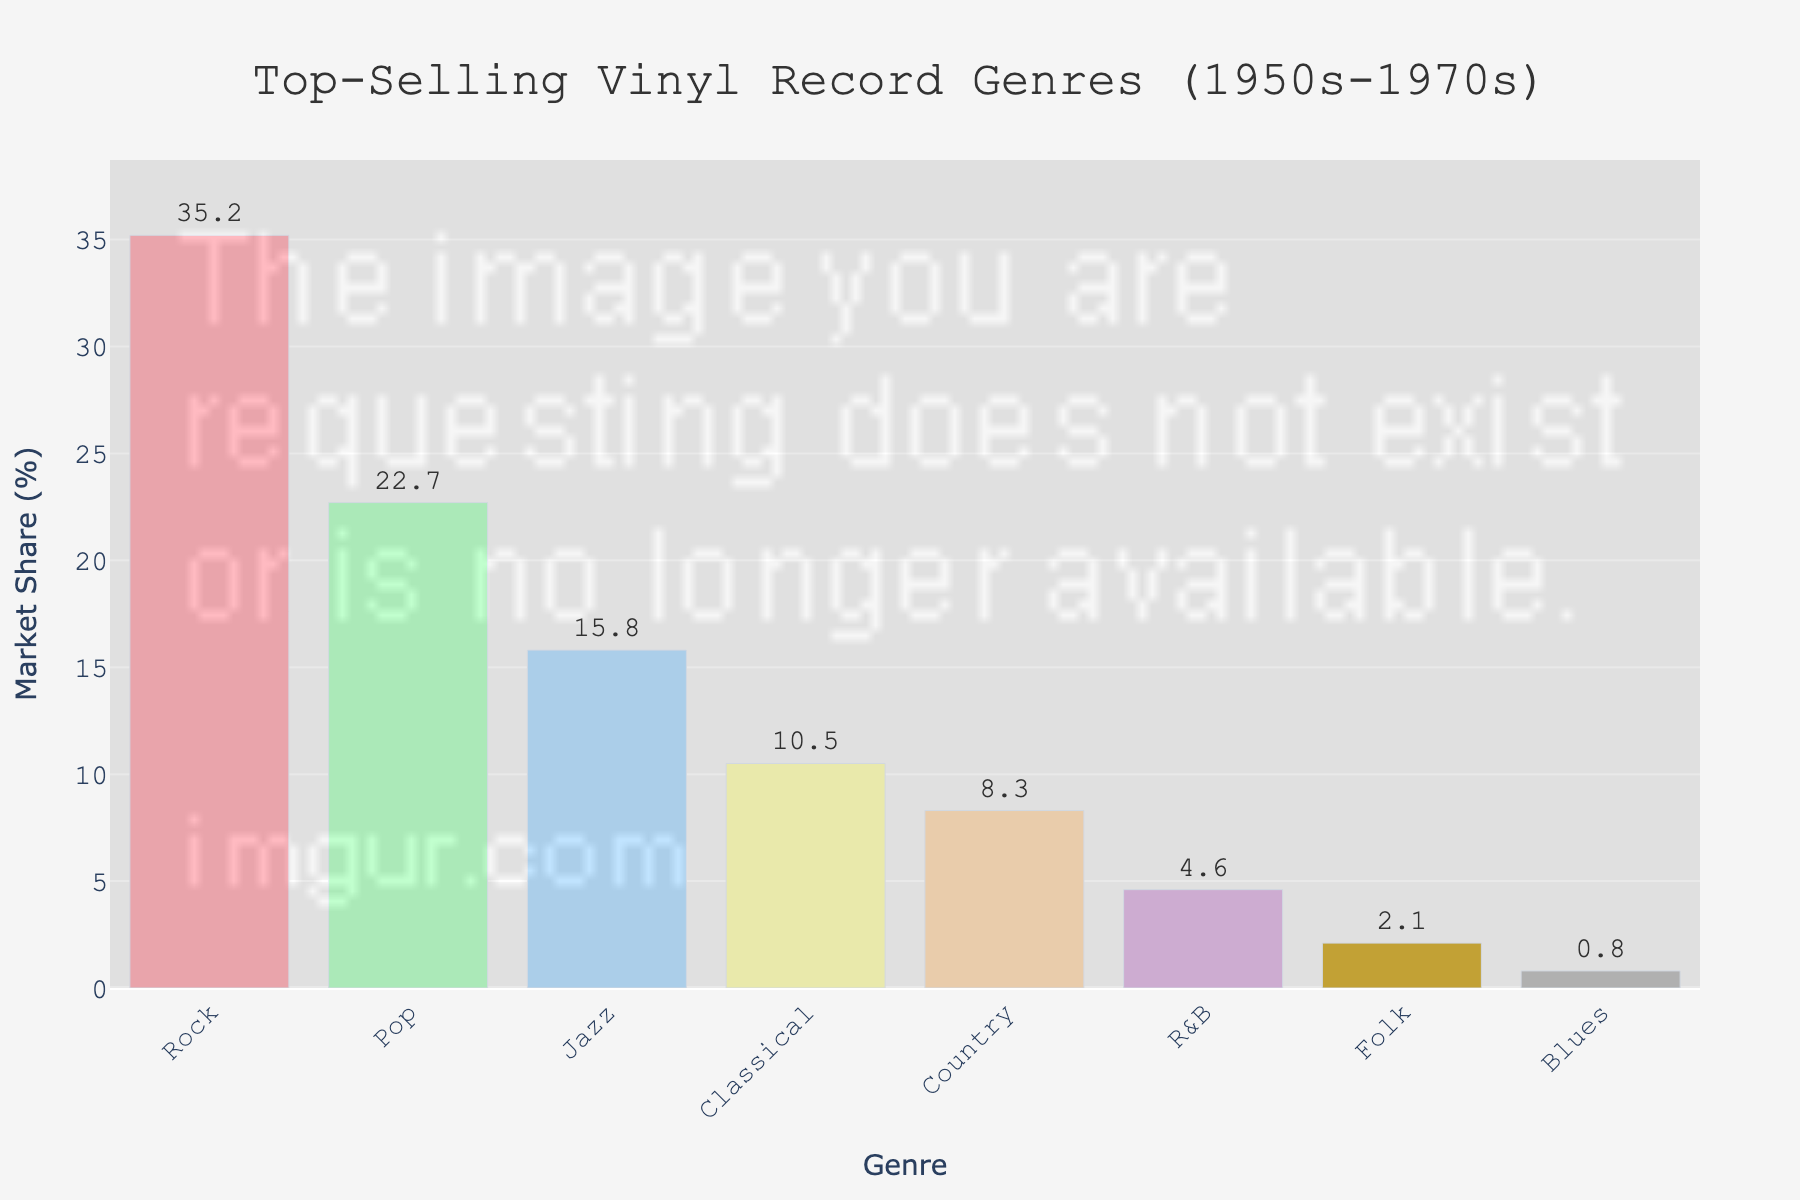What's the total market share of the genres Rock and Pop combined? To find the total market share of Rock and Pop combined, add their respective market shares: Rock (35.2%) + Pop (22.7%) = 57.9%.
Answer: 57.9% Which genre has the smallest market share? The smallest market share is visually represented by the shortest bar. The Blues genre has the smallest bar with a market share of 0.8%.
Answer: Blues What is the difference in market share between Jazz and Classical genres? Subtract the market share of Classical (10.5%) from the market share of Jazz (15.8%): 15.8% - 10.5% = 5.3%.
Answer: 5.3% How many genres have a market share greater than 10%? By looking at the bars, identify the genres with a market share greater than 10%. These are Rock, Pop, and Jazz. So, three genres have a market share greater than 10%.
Answer: 3 Is the market share of Rock genre more than triple that of Country genre? Determine if the market share of Rock (35.2%) is more than three times the market share of Country (8.3%). Calculate 8.3% * 3 = 24.9%. Since 35.2% > 24.9%, yes, it is more.
Answer: Yes What is the average market share of the top three genres? Add the market shares of the top three genres (Rock, Pop, Jazz) and divide by three: (35.2% + 22.7% + 15.8%) / 3 ≈ 24.57%.
Answer: 24.57% Which genres have a market share less than 5%? Identify the genres with a market share less than 5% by visually analyzing the bars. These are R&B, Folk, and Blues.
Answer: R&B, Folk, Blues How much greater is the market share of Folk than Blues? Subtract the market share of Blues (0.8%) from the market share of Folk (2.1%): 2.1% - 0.8% = 1.3%.
Answer: 1.3% What is the range of the market shares in the figure? The range is calculated by subtracting the smallest market share (Blues, 0.8%) from the largest market share (Rock, 35.2%). 35.2% - 0.8% = 34.4%.
Answer: 34.4% 